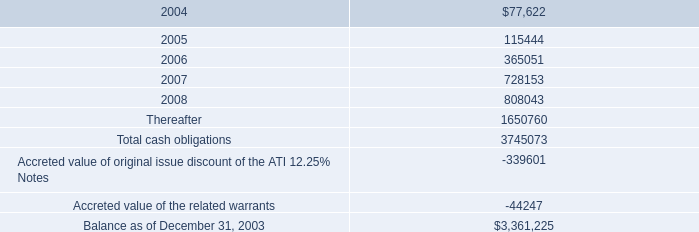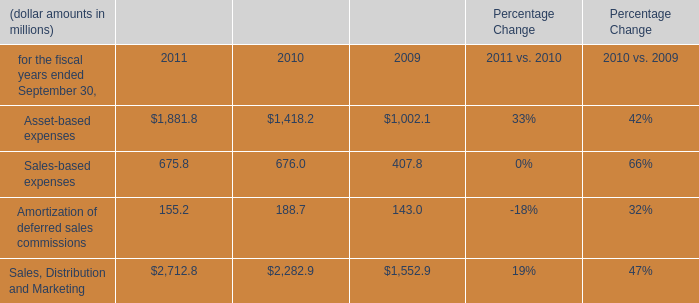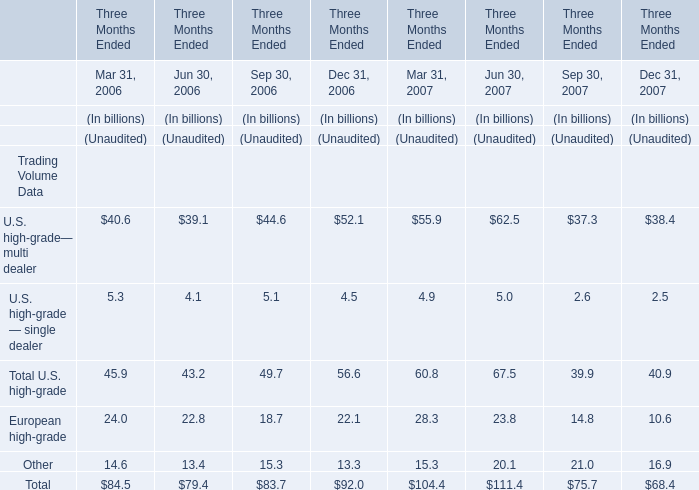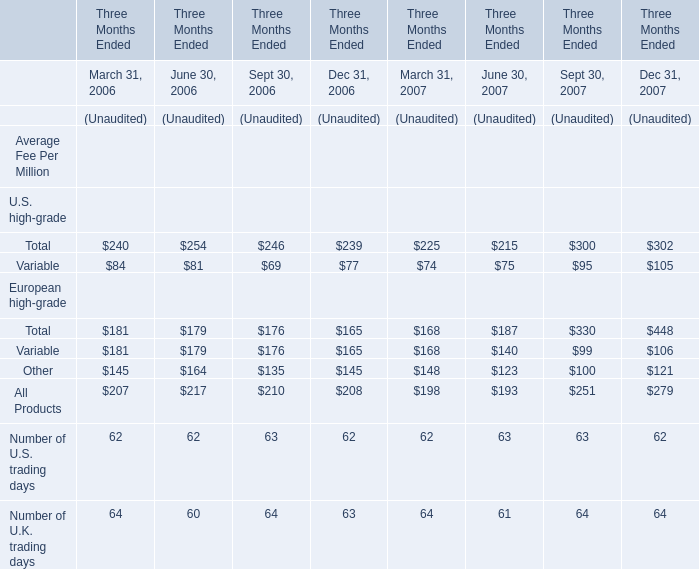For Mar 31, what year is Total Trading Volume larger? 
Answer: 2007. 